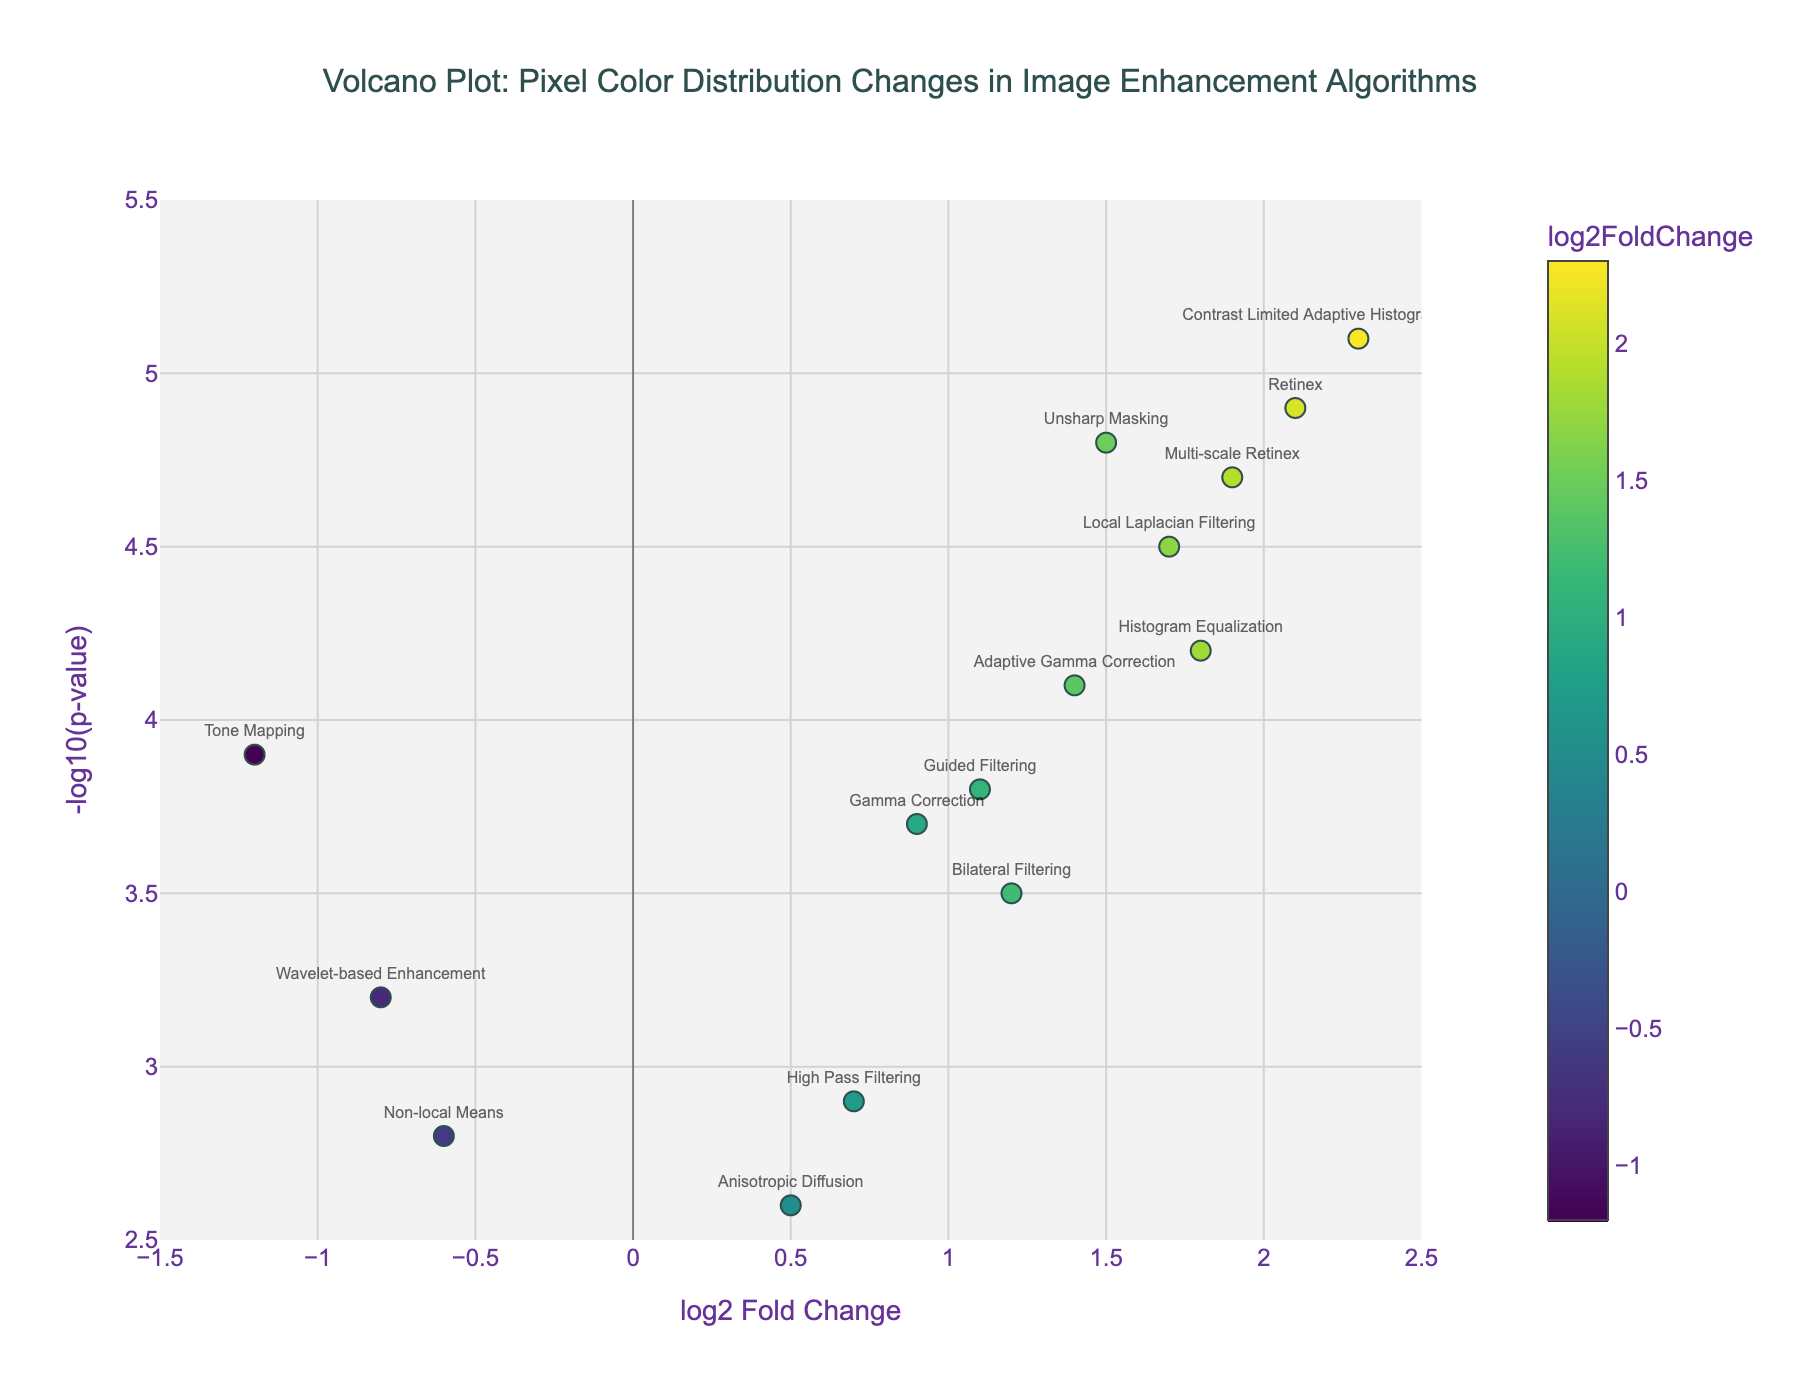How many image enhancement algorithms are displayed in the figure? Count the number of unique points displayed on the volcano plot. Each point represents an algorithm.
Answer: 15 What is the title of the plot? Look at the center top of the plot where the text is displayed.
Answer: Volcano Plot: Pixel Color Distribution Changes in Image Enhancement Algorithms Which algorithm has the highest log2 fold change? Identify the data point farthest to the right on the x-axis, then read the algorithm's name.
Answer: Contrast Limited Adaptive Histogram Equalization What is the range of the -log10(p-value) axis? Look at the y-axis to identify the minimum and maximum values displayed.
Answer: 2.5 to 5.5 Which two algorithms have negative log2 fold changes? Identify data points on the left side of the y-axis (where log2 fold change is negative) and note their algorithm names.
Answer: Wavelet-based Enhancement, Non-local Means How many algorithms have a -log10(p-value) greater than 4? Count the number of points on the plot located above the y-axis value of 4.
Answer: 8 Which algorithm has a -log10(p-value) closest to 4.0? Look along the y-axis around the value of 4.0 and identify the nearest data point's algorithm name.
Answer: Adaptive Gamma Correction Of the algorithms with log2 fold changes greater than 1.5, which has the lowest -log10(p-value)? Filter for data points to the right of 1.5 on the x-axis, then identify the one with the smallest y-axis value.
Answer: Local Laplacian Filtering Which algorithm shows a log2 fold change of 1.2? Find the data point where the x-axis value is 1.2 and read the associated algorithm name.
Answer: Bilateral Filtering Which algorithm has the smallest negative log2 fold change? Identify the data point furthest to the left but closest to zero on the x-axis and read the algorithm name.
Answer: Non-local Means 